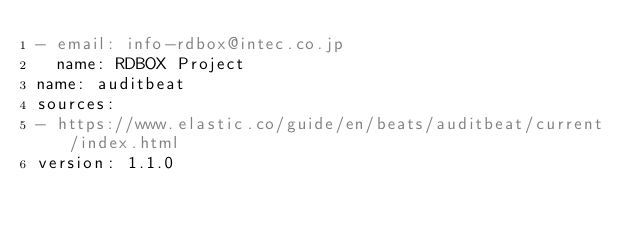<code> <loc_0><loc_0><loc_500><loc_500><_YAML_>- email: info-rdbox@intec.co.jp
  name: RDBOX Project
name: auditbeat
sources:
- https://www.elastic.co/guide/en/beats/auditbeat/current/index.html
version: 1.1.0
</code> 